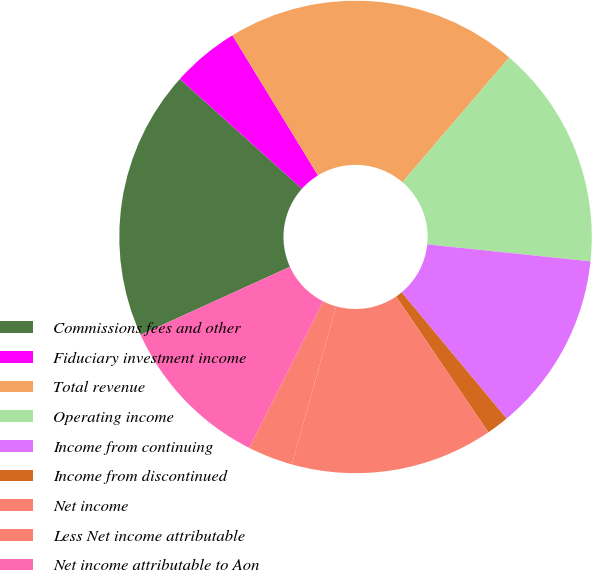Convert chart. <chart><loc_0><loc_0><loc_500><loc_500><pie_chart><fcel>Commissions fees and other<fcel>Fiduciary investment income<fcel>Total revenue<fcel>Operating income<fcel>Income from continuing<fcel>Income from discontinued<fcel>Net income<fcel>Less Net income attributable<fcel>Net income attributable to Aon<fcel>Dividends paid per share<nl><fcel>18.46%<fcel>4.62%<fcel>20.0%<fcel>15.38%<fcel>12.31%<fcel>1.54%<fcel>13.85%<fcel>3.08%<fcel>10.77%<fcel>0.0%<nl></chart> 